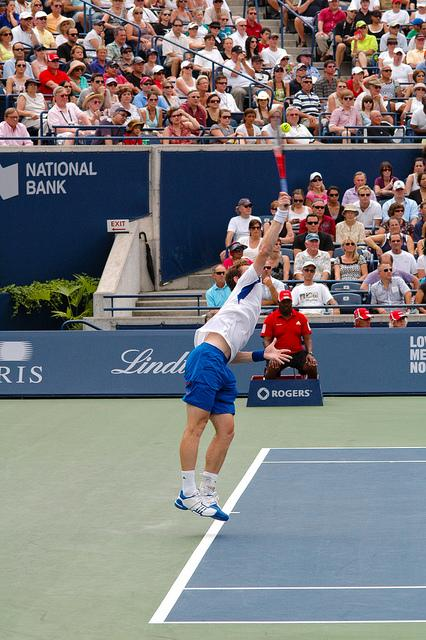Why is his arm up in the air?

Choices:
A) signal
B) balance
C) wave
D) reach reach 